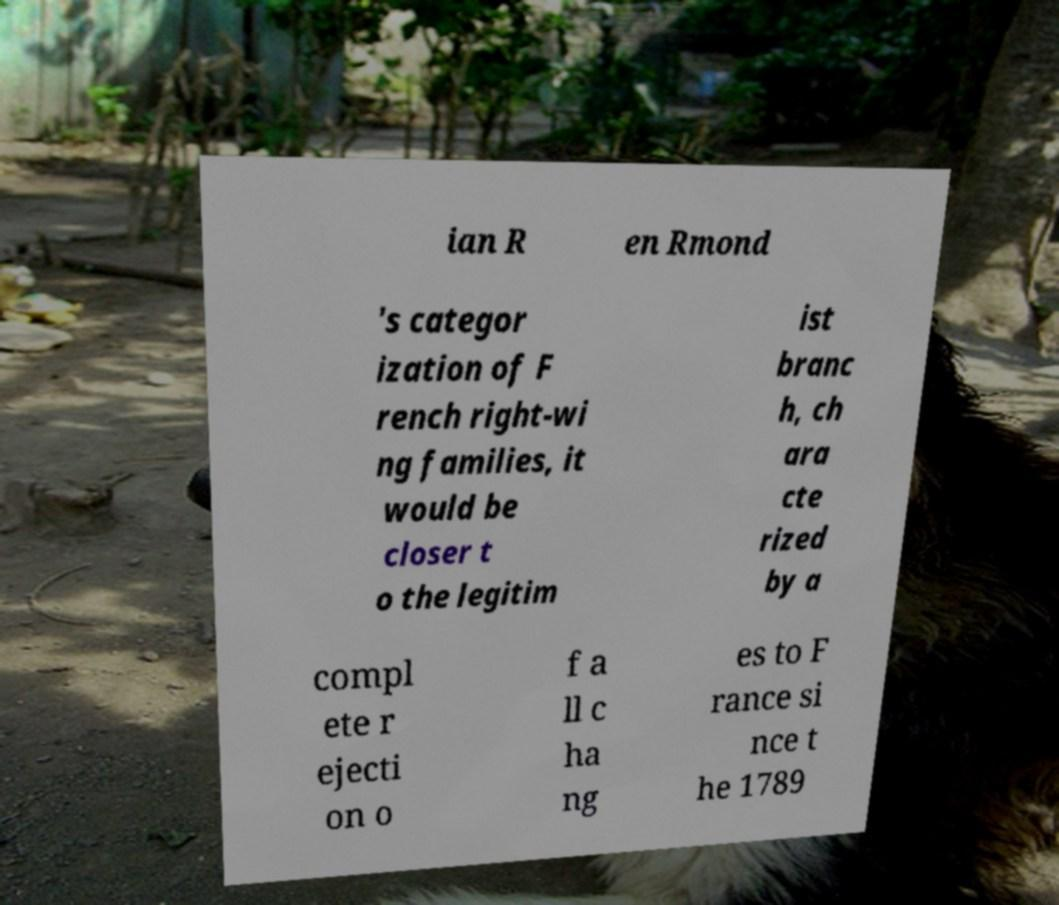Could you extract and type out the text from this image? ian R en Rmond 's categor ization of F rench right-wi ng families, it would be closer t o the legitim ist branc h, ch ara cte rized by a compl ete r ejecti on o f a ll c ha ng es to F rance si nce t he 1789 